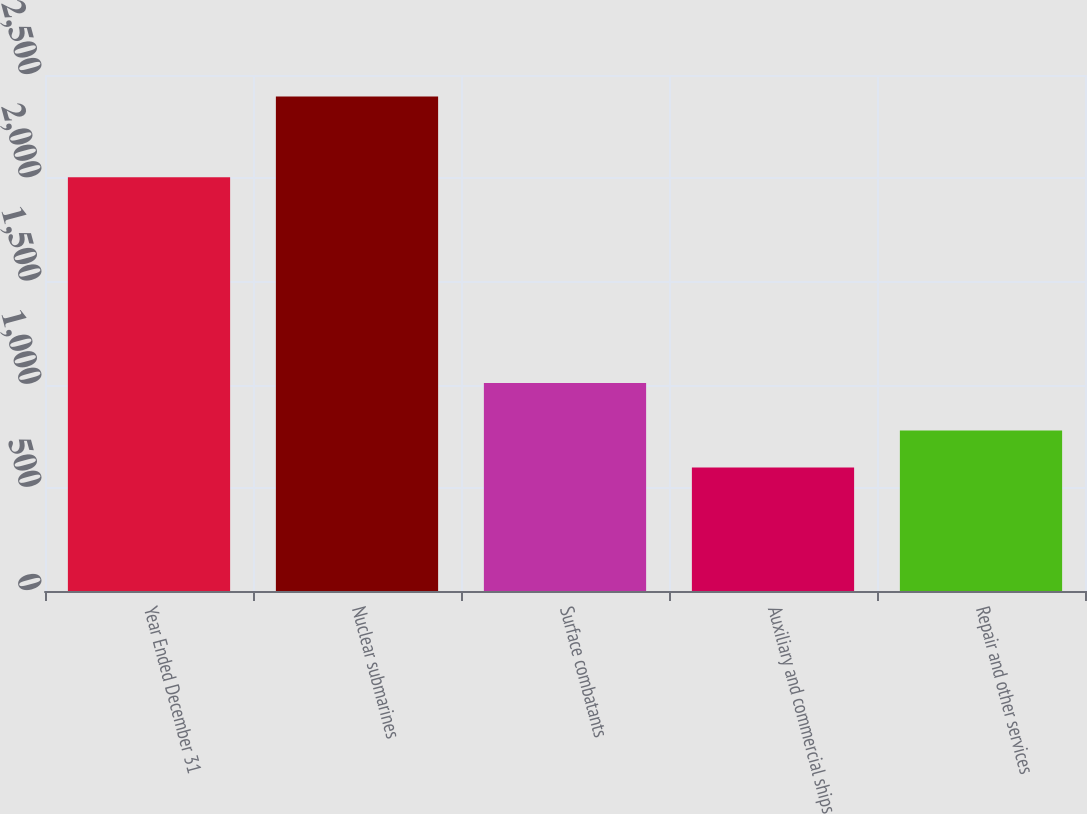Convert chart. <chart><loc_0><loc_0><loc_500><loc_500><bar_chart><fcel>Year Ended December 31<fcel>Nuclear submarines<fcel>Surface combatants<fcel>Auxiliary and commercial ships<fcel>Repair and other services<nl><fcel>2005<fcel>2396<fcel>1008<fcel>598<fcel>777.8<nl></chart> 